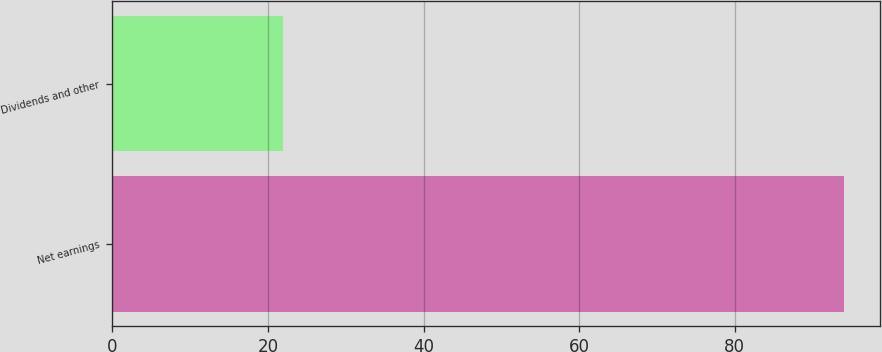Convert chart to OTSL. <chart><loc_0><loc_0><loc_500><loc_500><bar_chart><fcel>Net earnings<fcel>Dividends and other<nl><fcel>94<fcel>22<nl></chart> 